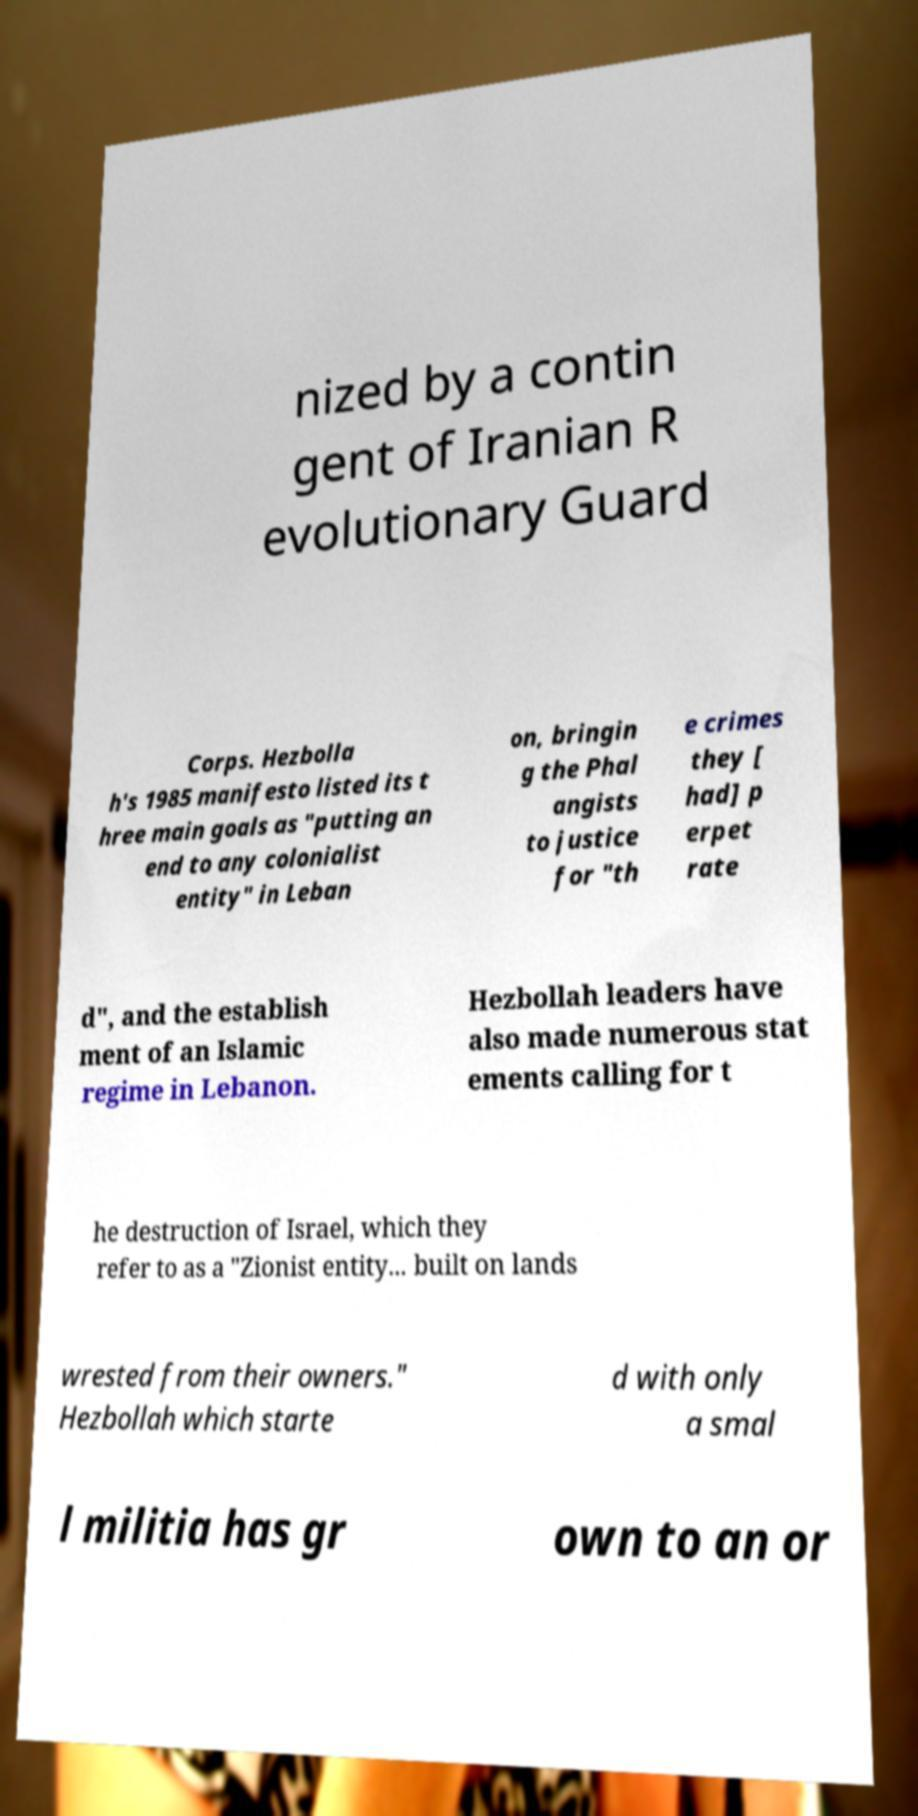Can you accurately transcribe the text from the provided image for me? nized by a contin gent of Iranian R evolutionary Guard Corps. Hezbolla h's 1985 manifesto listed its t hree main goals as "putting an end to any colonialist entity" in Leban on, bringin g the Phal angists to justice for "th e crimes they [ had] p erpet rate d", and the establish ment of an Islamic regime in Lebanon. Hezbollah leaders have also made numerous stat ements calling for t he destruction of Israel, which they refer to as a "Zionist entity... built on lands wrested from their owners." Hezbollah which starte d with only a smal l militia has gr own to an or 